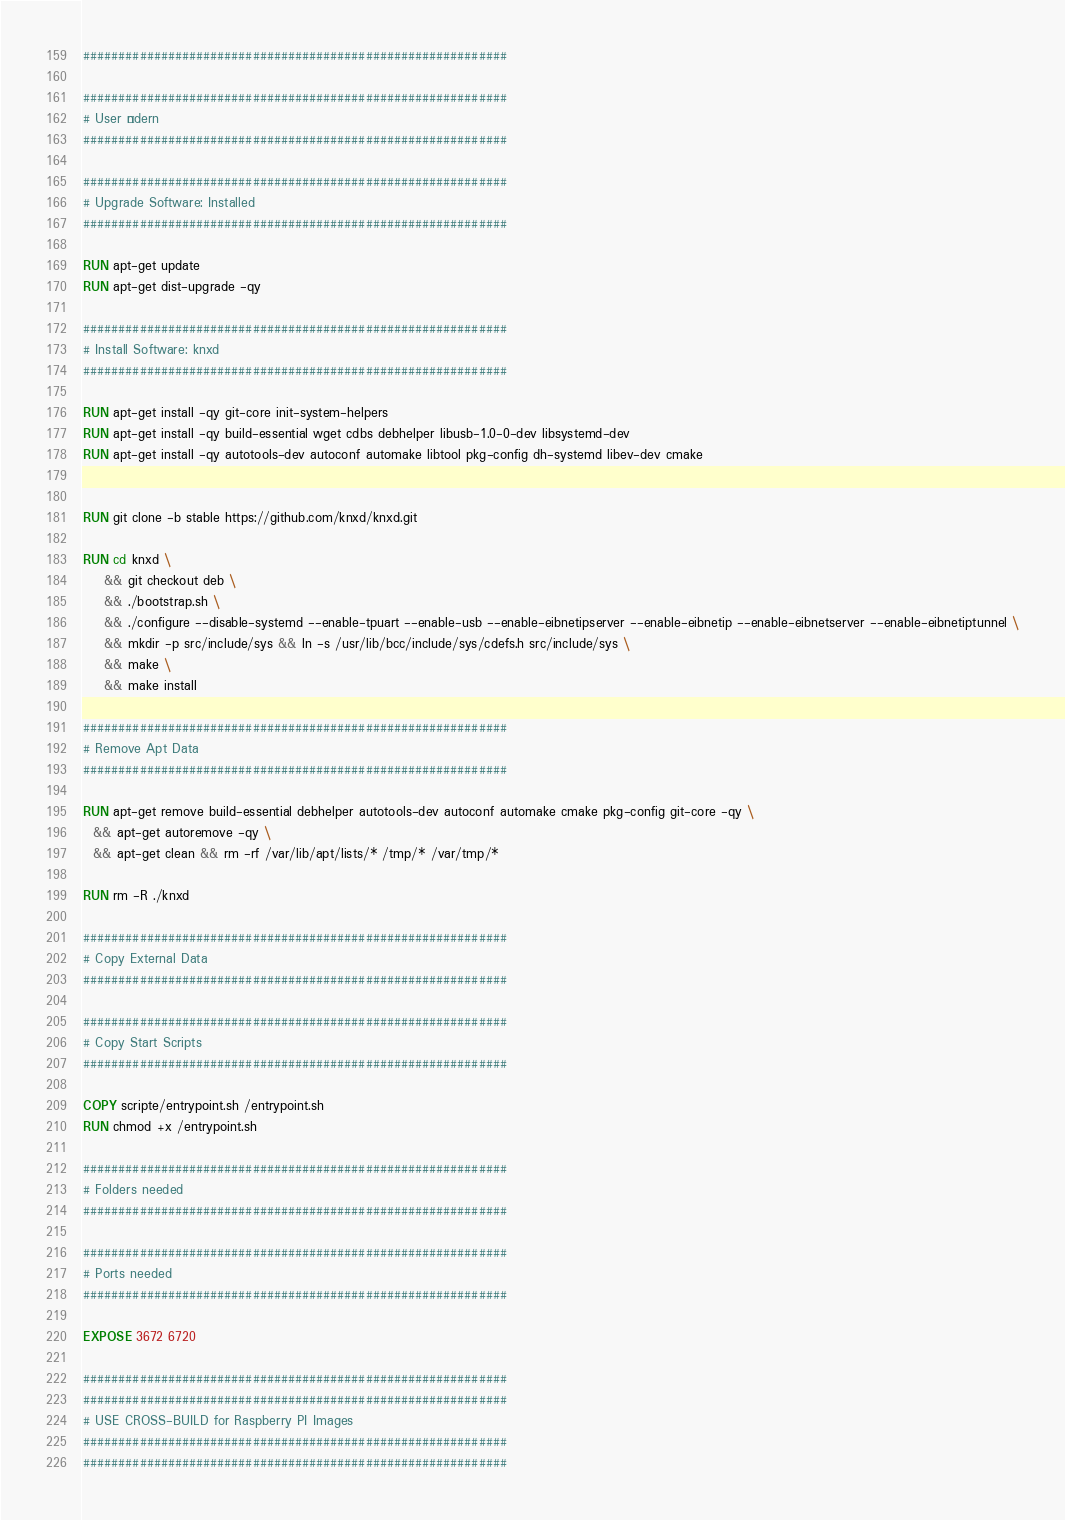Convert code to text. <code><loc_0><loc_0><loc_500><loc_500><_Dockerfile_>############################################################

############################################################
# User Ändern
############################################################

############################################################
# Upgrade Software: Installed
############################################################

RUN apt-get update
RUN apt-get dist-upgrade -qy

############################################################
# Install Software: knxd
############################################################

RUN apt-get install -qy git-core init-system-helpers
RUN apt-get install -qy build-essential wget cdbs debhelper libusb-1.0-0-dev libsystemd-dev 
RUN apt-get install -qy autotools-dev autoconf automake libtool pkg-config dh-systemd libev-dev cmake 


RUN git clone -b stable https://github.com/knxd/knxd.git

RUN cd knxd \
    && git checkout deb \
    && ./bootstrap.sh \
    && ./configure --disable-systemd --enable-tpuart --enable-usb --enable-eibnetipserver --enable-eibnetip --enable-eibnetserver --enable-eibnetiptunnel \
    && mkdir -p src/include/sys && ln -s /usr/lib/bcc/include/sys/cdefs.h src/include/sys \
    && make \
    && make install

############################################################
# Remove Apt Data
############################################################

RUN apt-get remove build-essential debhelper autotools-dev autoconf automake cmake pkg-config git-core -qy \
  && apt-get autoremove -qy \
  && apt-get clean && rm -rf /var/lib/apt/lists/* /tmp/* /var/tmp/*

RUN rm -R ./knxd

############################################################
# Copy External Data
############################################################

############################################################
# Copy Start Scripts
############################################################

COPY scripte/entrypoint.sh /entrypoint.sh
RUN chmod +x /entrypoint.sh

############################################################
# Folders needed
############################################################

############################################################
# Ports needed
############################################################

EXPOSE 3672 6720

############################################################
############################################################
# USE CROSS-BUILD for Raspberry PI Images
############################################################
############################################################
</code> 